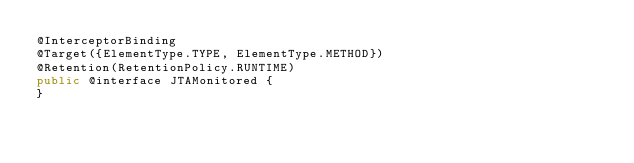<code> <loc_0><loc_0><loc_500><loc_500><_Java_>@InterceptorBinding
@Target({ElementType.TYPE, ElementType.METHOD})
@Retention(RetentionPolicy.RUNTIME)
public @interface JTAMonitored {
}
</code> 